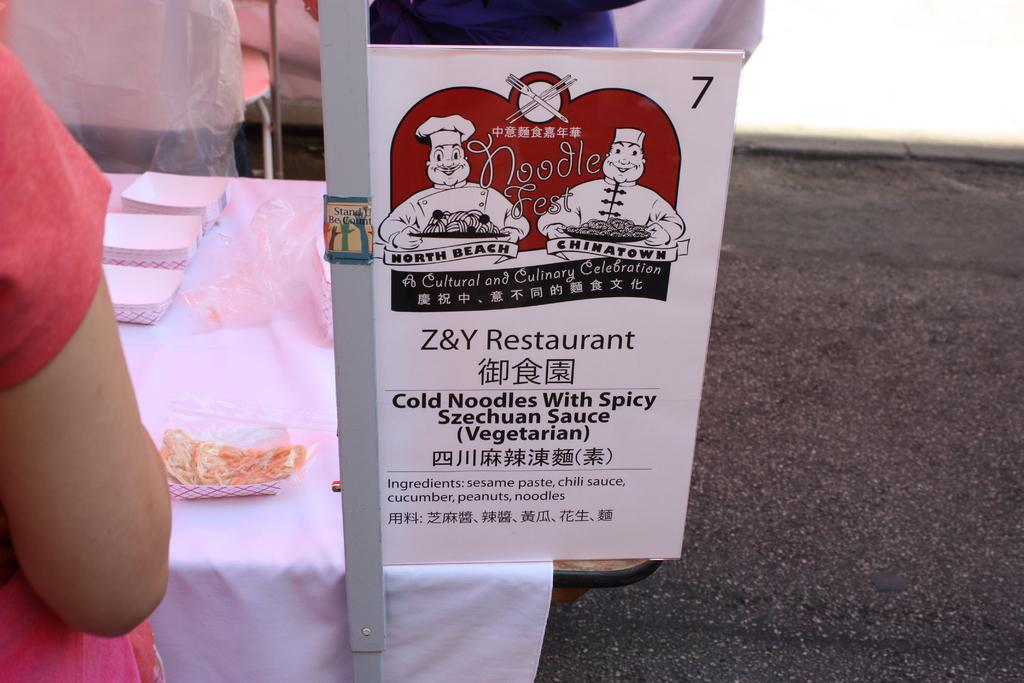What is written on the board in the image? There is a board with text in the image, but the specific text cannot be determined from the facts provided. What is the person's hand doing in the image? The person's hand is in front of a table, but the action or purpose of the hand cannot be determined from the facts provided. What types of objects are placed on the table in the image? The facts provided do not specify the types of objects placed on the table. What color is the shirt worn by the snails in the image? There are no snails or shirts present in the image. Is the oven turned on in the image? There is no oven present in the image. 